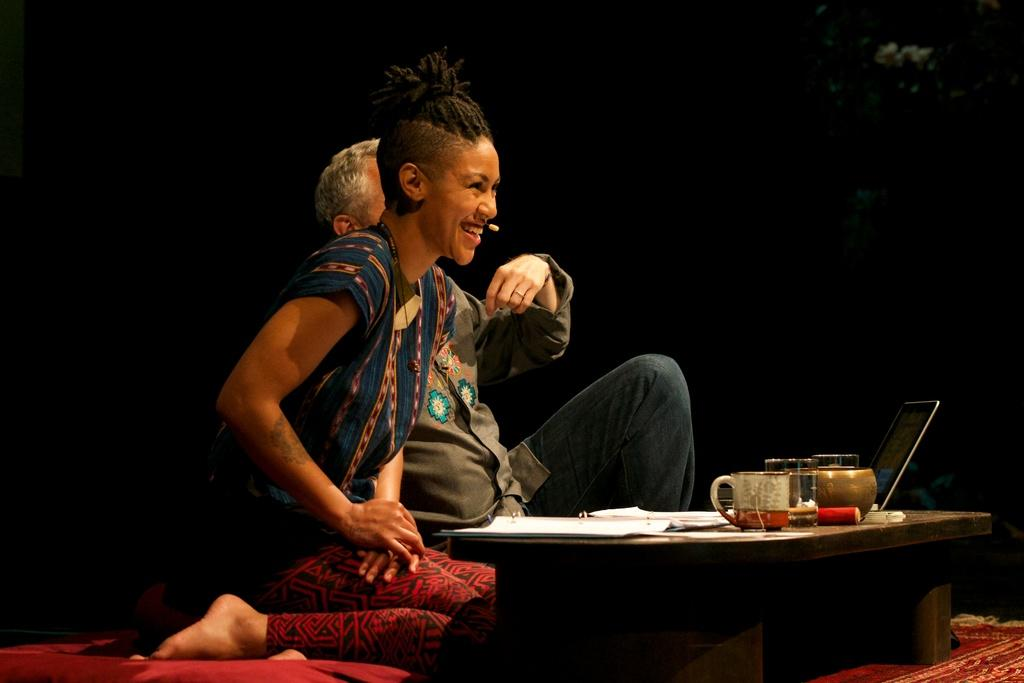How many people are in the image? There are two people in the center of the image. What is in front of the people? There is a stool in front of the people. What items are on the stool? There are papers, cups, and a laptop on the stool. What type of eye can be seen on the laptop in the image? There is no eye present on the laptop in the image. 